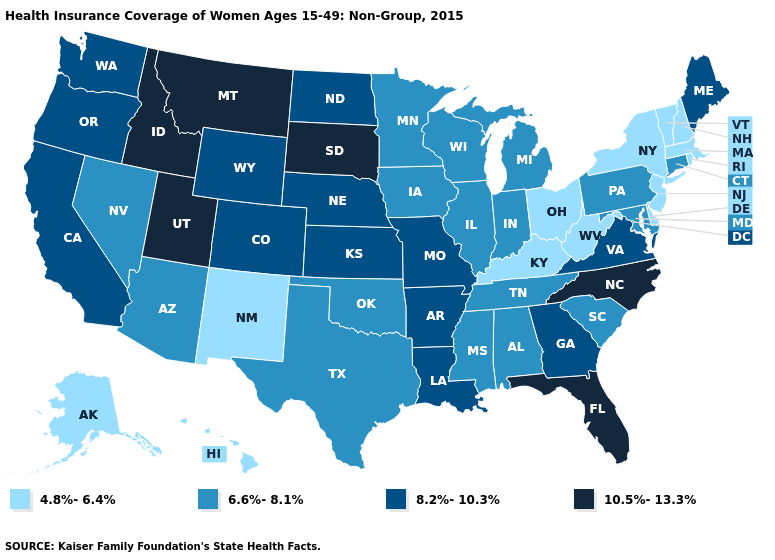Name the states that have a value in the range 8.2%-10.3%?
Give a very brief answer. Arkansas, California, Colorado, Georgia, Kansas, Louisiana, Maine, Missouri, Nebraska, North Dakota, Oregon, Virginia, Washington, Wyoming. Which states have the lowest value in the USA?
Quick response, please. Alaska, Delaware, Hawaii, Kentucky, Massachusetts, New Hampshire, New Jersey, New Mexico, New York, Ohio, Rhode Island, Vermont, West Virginia. What is the value of Maine?
Answer briefly. 8.2%-10.3%. What is the value of Connecticut?
Give a very brief answer. 6.6%-8.1%. Among the states that border California , does Arizona have the highest value?
Give a very brief answer. No. Name the states that have a value in the range 4.8%-6.4%?
Give a very brief answer. Alaska, Delaware, Hawaii, Kentucky, Massachusetts, New Hampshire, New Jersey, New Mexico, New York, Ohio, Rhode Island, Vermont, West Virginia. What is the lowest value in the West?
Keep it brief. 4.8%-6.4%. Does Montana have the highest value in the USA?
Write a very short answer. Yes. What is the value of South Carolina?
Be succinct. 6.6%-8.1%. Does the first symbol in the legend represent the smallest category?
Short answer required. Yes. What is the highest value in states that border Arizona?
Quick response, please. 10.5%-13.3%. What is the highest value in the West ?
Keep it brief. 10.5%-13.3%. Name the states that have a value in the range 10.5%-13.3%?
Write a very short answer. Florida, Idaho, Montana, North Carolina, South Dakota, Utah. Name the states that have a value in the range 8.2%-10.3%?
Answer briefly. Arkansas, California, Colorado, Georgia, Kansas, Louisiana, Maine, Missouri, Nebraska, North Dakota, Oregon, Virginia, Washington, Wyoming. Does Washington have the lowest value in the West?
Keep it brief. No. 